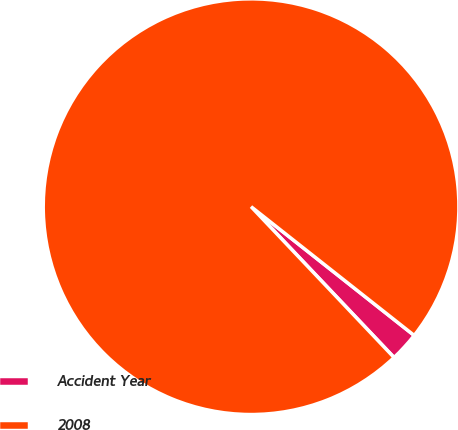<chart> <loc_0><loc_0><loc_500><loc_500><pie_chart><fcel>Accident Year<fcel>2008<nl><fcel>2.29%<fcel>97.71%<nl></chart> 